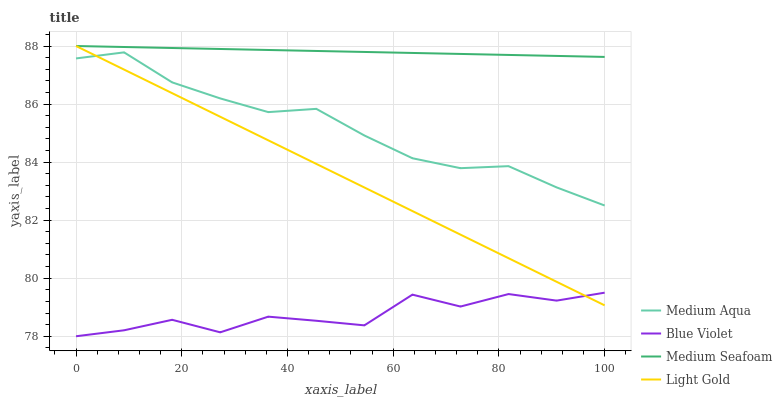Does Blue Violet have the minimum area under the curve?
Answer yes or no. Yes. Does Medium Seafoam have the maximum area under the curve?
Answer yes or no. Yes. Does Medium Aqua have the minimum area under the curve?
Answer yes or no. No. Does Medium Aqua have the maximum area under the curve?
Answer yes or no. No. Is Medium Seafoam the smoothest?
Answer yes or no. Yes. Is Blue Violet the roughest?
Answer yes or no. Yes. Is Medium Aqua the smoothest?
Answer yes or no. No. Is Medium Aqua the roughest?
Answer yes or no. No. Does Blue Violet have the lowest value?
Answer yes or no. Yes. Does Medium Aqua have the lowest value?
Answer yes or no. No. Does Medium Seafoam have the highest value?
Answer yes or no. Yes. Does Medium Aqua have the highest value?
Answer yes or no. No. Is Blue Violet less than Medium Aqua?
Answer yes or no. Yes. Is Medium Seafoam greater than Blue Violet?
Answer yes or no. Yes. Does Light Gold intersect Blue Violet?
Answer yes or no. Yes. Is Light Gold less than Blue Violet?
Answer yes or no. No. Is Light Gold greater than Blue Violet?
Answer yes or no. No. Does Blue Violet intersect Medium Aqua?
Answer yes or no. No. 